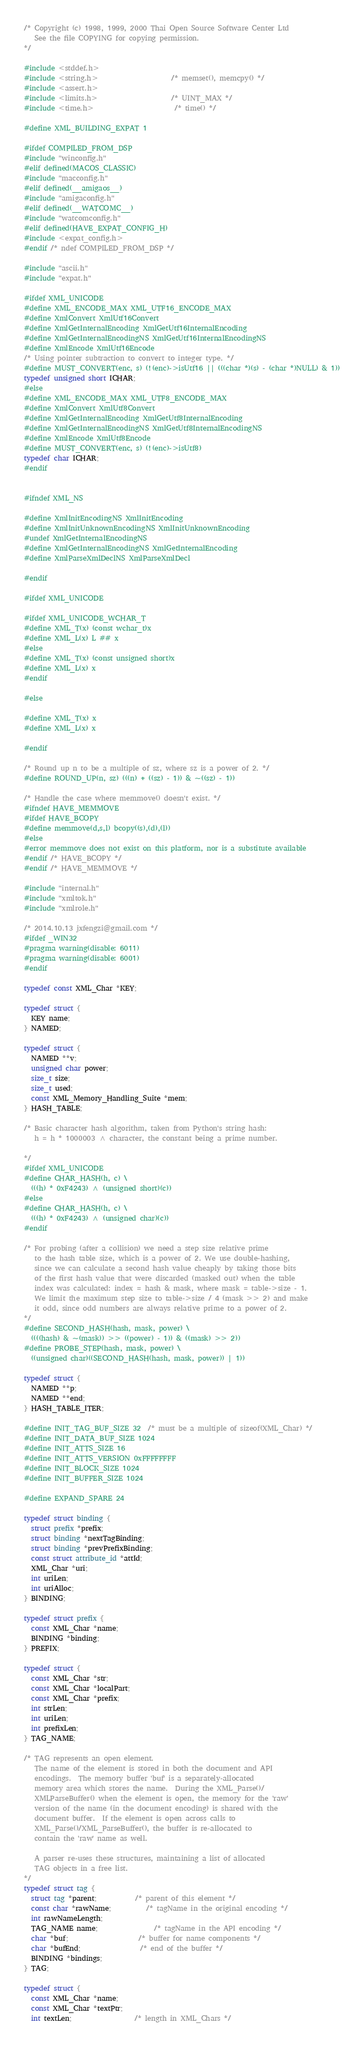<code> <loc_0><loc_0><loc_500><loc_500><_C_>/* Copyright (c) 1998, 1999, 2000 Thai Open Source Software Center Ltd
   See the file COPYING for copying permission.
*/

#include <stddef.h>
#include <string.h>                     /* memset(), memcpy() */
#include <assert.h>
#include <limits.h>                     /* UINT_MAX */
#include <time.h>                       /* time() */

#define XML_BUILDING_EXPAT 1

#ifdef COMPILED_FROM_DSP
#include "winconfig.h"
#elif defined(MACOS_CLASSIC)
#include "macconfig.h"
#elif defined(__amigaos__)
#include "amigaconfig.h"
#elif defined(__WATCOMC__)
#include "watcomconfig.h"
#elif defined(HAVE_EXPAT_CONFIG_H)
#include <expat_config.h>
#endif /* ndef COMPILED_FROM_DSP */

#include "ascii.h"
#include "expat.h"

#ifdef XML_UNICODE
#define XML_ENCODE_MAX XML_UTF16_ENCODE_MAX
#define XmlConvert XmlUtf16Convert
#define XmlGetInternalEncoding XmlGetUtf16InternalEncoding
#define XmlGetInternalEncodingNS XmlGetUtf16InternalEncodingNS
#define XmlEncode XmlUtf16Encode
/* Using pointer subtraction to convert to integer type. */
#define MUST_CONVERT(enc, s) (!(enc)->isUtf16 || (((char *)(s) - (char *)NULL) & 1))
typedef unsigned short ICHAR;
#else
#define XML_ENCODE_MAX XML_UTF8_ENCODE_MAX
#define XmlConvert XmlUtf8Convert
#define XmlGetInternalEncoding XmlGetUtf8InternalEncoding
#define XmlGetInternalEncodingNS XmlGetUtf8InternalEncodingNS
#define XmlEncode XmlUtf8Encode
#define MUST_CONVERT(enc, s) (!(enc)->isUtf8)
typedef char ICHAR;
#endif


#ifndef XML_NS

#define XmlInitEncodingNS XmlInitEncoding
#define XmlInitUnknownEncodingNS XmlInitUnknownEncoding
#undef XmlGetInternalEncodingNS
#define XmlGetInternalEncodingNS XmlGetInternalEncoding
#define XmlParseXmlDeclNS XmlParseXmlDecl

#endif

#ifdef XML_UNICODE

#ifdef XML_UNICODE_WCHAR_T
#define XML_T(x) (const wchar_t)x
#define XML_L(x) L ## x
#else
#define XML_T(x) (const unsigned short)x
#define XML_L(x) x
#endif

#else

#define XML_T(x) x
#define XML_L(x) x

#endif

/* Round up n to be a multiple of sz, where sz is a power of 2. */
#define ROUND_UP(n, sz) (((n) + ((sz) - 1)) & ~((sz) - 1))

/* Handle the case where memmove() doesn't exist. */
#ifndef HAVE_MEMMOVE
#ifdef HAVE_BCOPY
#define memmove(d,s,l) bcopy((s),(d),(l))
#else
#error memmove does not exist on this platform, nor is a substitute available
#endif /* HAVE_BCOPY */
#endif /* HAVE_MEMMOVE */

#include "internal.h"
#include "xmltok.h"
#include "xmlrole.h"

/* 2014.10.13 jxfengzi@gmail.com */
#ifdef _WIN32
#pragma warning(disable: 6011)
#pragma warning(disable: 6001)
#endif

typedef const XML_Char *KEY;

typedef struct {
  KEY name;
} NAMED;

typedef struct {
  NAMED **v;
  unsigned char power;
  size_t size;
  size_t used;
  const XML_Memory_Handling_Suite *mem;
} HASH_TABLE;

/* Basic character hash algorithm, taken from Python's string hash:
   h = h * 1000003 ^ character, the constant being a prime number.

*/
#ifdef XML_UNICODE
#define CHAR_HASH(h, c) \
  (((h) * 0xF4243) ^ (unsigned short)(c))
#else
#define CHAR_HASH(h, c) \
  (((h) * 0xF4243) ^ (unsigned char)(c))
#endif

/* For probing (after a collision) we need a step size relative prime
   to the hash table size, which is a power of 2. We use double-hashing,
   since we can calculate a second hash value cheaply by taking those bits
   of the first hash value that were discarded (masked out) when the table
   index was calculated: index = hash & mask, where mask = table->size - 1.
   We limit the maximum step size to table->size / 4 (mask >> 2) and make
   it odd, since odd numbers are always relative prime to a power of 2.
*/
#define SECOND_HASH(hash, mask, power) \
  ((((hash) & ~(mask)) >> ((power) - 1)) & ((mask) >> 2))
#define PROBE_STEP(hash, mask, power) \
  ((unsigned char)((SECOND_HASH(hash, mask, power)) | 1))

typedef struct {
  NAMED **p;
  NAMED **end;
} HASH_TABLE_ITER;

#define INIT_TAG_BUF_SIZE 32  /* must be a multiple of sizeof(XML_Char) */
#define INIT_DATA_BUF_SIZE 1024
#define INIT_ATTS_SIZE 16
#define INIT_ATTS_VERSION 0xFFFFFFFF
#define INIT_BLOCK_SIZE 1024
#define INIT_BUFFER_SIZE 1024

#define EXPAND_SPARE 24

typedef struct binding {
  struct prefix *prefix;
  struct binding *nextTagBinding;
  struct binding *prevPrefixBinding;
  const struct attribute_id *attId;
  XML_Char *uri;
  int uriLen;
  int uriAlloc;
} BINDING;

typedef struct prefix {
  const XML_Char *name;
  BINDING *binding;
} PREFIX;

typedef struct {
  const XML_Char *str;
  const XML_Char *localPart;
  const XML_Char *prefix;
  int strLen;
  int uriLen;
  int prefixLen;
} TAG_NAME;

/* TAG represents an open element.
   The name of the element is stored in both the document and API
   encodings.  The memory buffer 'buf' is a separately-allocated
   memory area which stores the name.  During the XML_Parse()/
   XMLParseBuffer() when the element is open, the memory for the 'raw'
   version of the name (in the document encoding) is shared with the
   document buffer.  If the element is open across calls to
   XML_Parse()/XML_ParseBuffer(), the buffer is re-allocated to
   contain the 'raw' name as well.

   A parser re-uses these structures, maintaining a list of allocated
   TAG objects in a free list.
*/
typedef struct tag {
  struct tag *parent;           /* parent of this element */
  const char *rawName;          /* tagName in the original encoding */
  int rawNameLength;
  TAG_NAME name;                /* tagName in the API encoding */
  char *buf;                    /* buffer for name components */
  char *bufEnd;                 /* end of the buffer */
  BINDING *bindings;
} TAG;

typedef struct {
  const XML_Char *name;
  const XML_Char *textPtr;
  int textLen;                  /* length in XML_Chars */</code> 